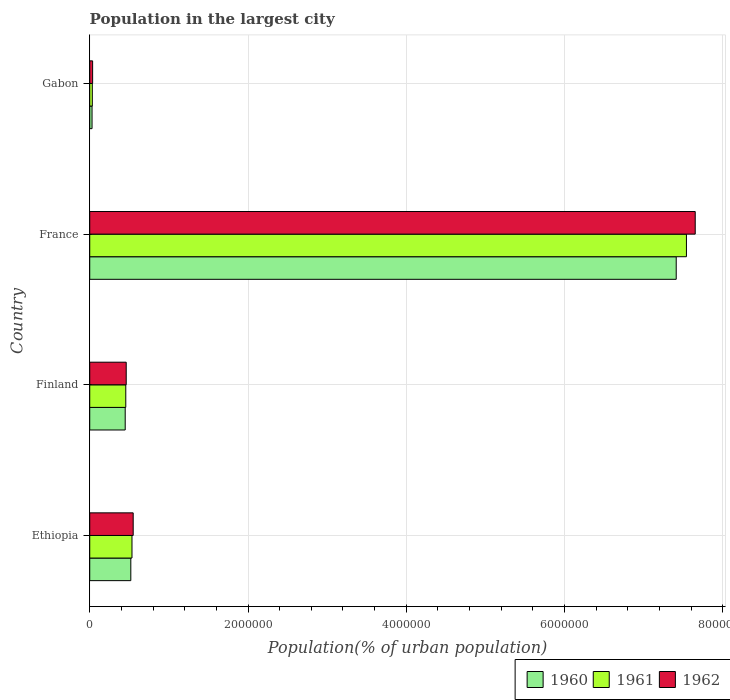How many different coloured bars are there?
Your response must be concise. 3. Are the number of bars on each tick of the Y-axis equal?
Provide a short and direct response. Yes. How many bars are there on the 3rd tick from the bottom?
Provide a short and direct response. 3. What is the label of the 3rd group of bars from the top?
Provide a short and direct response. Finland. What is the population in the largest city in 1960 in Gabon?
Provide a succinct answer. 2.92e+04. Across all countries, what is the maximum population in the largest city in 1961?
Make the answer very short. 7.54e+06. Across all countries, what is the minimum population in the largest city in 1960?
Offer a terse response. 2.92e+04. In which country was the population in the largest city in 1962 minimum?
Offer a terse response. Gabon. What is the total population in the largest city in 1960 in the graph?
Offer a very short reply. 8.41e+06. What is the difference between the population in the largest city in 1960 in Ethiopia and that in France?
Keep it short and to the point. -6.89e+06. What is the difference between the population in the largest city in 1960 in France and the population in the largest city in 1961 in Finland?
Ensure brevity in your answer.  6.96e+06. What is the average population in the largest city in 1962 per country?
Your answer should be compact. 2.17e+06. What is the difference between the population in the largest city in 1960 and population in the largest city in 1961 in France?
Give a very brief answer. -1.29e+05. What is the ratio of the population in the largest city in 1961 in France to that in Gabon?
Your response must be concise. 231.24. What is the difference between the highest and the second highest population in the largest city in 1962?
Offer a terse response. 7.10e+06. What is the difference between the highest and the lowest population in the largest city in 1961?
Offer a terse response. 7.51e+06. Is the sum of the population in the largest city in 1960 in Finland and Gabon greater than the maximum population in the largest city in 1961 across all countries?
Your answer should be compact. No. What does the 1st bar from the bottom in Finland represents?
Your answer should be very brief. 1960. How many bars are there?
Provide a short and direct response. 12. Are all the bars in the graph horizontal?
Ensure brevity in your answer.  Yes. How many countries are there in the graph?
Your answer should be compact. 4. What is the difference between two consecutive major ticks on the X-axis?
Keep it short and to the point. 2.00e+06. Are the values on the major ticks of X-axis written in scientific E-notation?
Ensure brevity in your answer.  No. Does the graph contain any zero values?
Give a very brief answer. No. Where does the legend appear in the graph?
Offer a terse response. Bottom right. How many legend labels are there?
Provide a short and direct response. 3. What is the title of the graph?
Your response must be concise. Population in the largest city. Does "2005" appear as one of the legend labels in the graph?
Provide a succinct answer. No. What is the label or title of the X-axis?
Keep it short and to the point. Population(% of urban population). What is the Population(% of urban population) of 1960 in Ethiopia?
Offer a very short reply. 5.19e+05. What is the Population(% of urban population) in 1961 in Ethiopia?
Your answer should be very brief. 5.34e+05. What is the Population(% of urban population) of 1962 in Ethiopia?
Offer a terse response. 5.49e+05. What is the Population(% of urban population) of 1960 in Finland?
Offer a very short reply. 4.48e+05. What is the Population(% of urban population) of 1961 in Finland?
Offer a terse response. 4.55e+05. What is the Population(% of urban population) in 1962 in Finland?
Your response must be concise. 4.61e+05. What is the Population(% of urban population) of 1960 in France?
Make the answer very short. 7.41e+06. What is the Population(% of urban population) of 1961 in France?
Your answer should be very brief. 7.54e+06. What is the Population(% of urban population) of 1962 in France?
Your response must be concise. 7.65e+06. What is the Population(% of urban population) in 1960 in Gabon?
Give a very brief answer. 2.92e+04. What is the Population(% of urban population) in 1961 in Gabon?
Offer a terse response. 3.26e+04. What is the Population(% of urban population) in 1962 in Gabon?
Make the answer very short. 3.65e+04. Across all countries, what is the maximum Population(% of urban population) of 1960?
Your answer should be compact. 7.41e+06. Across all countries, what is the maximum Population(% of urban population) of 1961?
Keep it short and to the point. 7.54e+06. Across all countries, what is the maximum Population(% of urban population) of 1962?
Provide a succinct answer. 7.65e+06. Across all countries, what is the minimum Population(% of urban population) in 1960?
Offer a very short reply. 2.92e+04. Across all countries, what is the minimum Population(% of urban population) in 1961?
Offer a very short reply. 3.26e+04. Across all countries, what is the minimum Population(% of urban population) of 1962?
Make the answer very short. 3.65e+04. What is the total Population(% of urban population) of 1960 in the graph?
Offer a terse response. 8.41e+06. What is the total Population(% of urban population) of 1961 in the graph?
Your answer should be compact. 8.56e+06. What is the total Population(% of urban population) in 1962 in the graph?
Your response must be concise. 8.70e+06. What is the difference between the Population(% of urban population) in 1960 in Ethiopia and that in Finland?
Make the answer very short. 7.10e+04. What is the difference between the Population(% of urban population) in 1961 in Ethiopia and that in Finland?
Give a very brief answer. 7.85e+04. What is the difference between the Population(% of urban population) of 1962 in Ethiopia and that in Finland?
Your answer should be very brief. 8.82e+04. What is the difference between the Population(% of urban population) in 1960 in Ethiopia and that in France?
Give a very brief answer. -6.89e+06. What is the difference between the Population(% of urban population) in 1961 in Ethiopia and that in France?
Your answer should be compact. -7.01e+06. What is the difference between the Population(% of urban population) of 1962 in Ethiopia and that in France?
Ensure brevity in your answer.  -7.10e+06. What is the difference between the Population(% of urban population) in 1960 in Ethiopia and that in Gabon?
Keep it short and to the point. 4.90e+05. What is the difference between the Population(% of urban population) in 1961 in Ethiopia and that in Gabon?
Offer a very short reply. 5.01e+05. What is the difference between the Population(% of urban population) in 1962 in Ethiopia and that in Gabon?
Your answer should be very brief. 5.13e+05. What is the difference between the Population(% of urban population) of 1960 in Finland and that in France?
Offer a terse response. -6.96e+06. What is the difference between the Population(% of urban population) in 1961 in Finland and that in France?
Make the answer very short. -7.08e+06. What is the difference between the Population(% of urban population) in 1962 in Finland and that in France?
Offer a terse response. -7.19e+06. What is the difference between the Population(% of urban population) in 1960 in Finland and that in Gabon?
Your answer should be very brief. 4.19e+05. What is the difference between the Population(% of urban population) in 1961 in Finland and that in Gabon?
Offer a terse response. 4.23e+05. What is the difference between the Population(% of urban population) of 1962 in Finland and that in Gabon?
Offer a very short reply. 4.24e+05. What is the difference between the Population(% of urban population) of 1960 in France and that in Gabon?
Your answer should be very brief. 7.38e+06. What is the difference between the Population(% of urban population) of 1961 in France and that in Gabon?
Keep it short and to the point. 7.51e+06. What is the difference between the Population(% of urban population) of 1962 in France and that in Gabon?
Ensure brevity in your answer.  7.61e+06. What is the difference between the Population(% of urban population) of 1960 in Ethiopia and the Population(% of urban population) of 1961 in Finland?
Provide a succinct answer. 6.37e+04. What is the difference between the Population(% of urban population) in 1960 in Ethiopia and the Population(% of urban population) in 1962 in Finland?
Your answer should be very brief. 5.82e+04. What is the difference between the Population(% of urban population) of 1961 in Ethiopia and the Population(% of urban population) of 1962 in Finland?
Your response must be concise. 7.30e+04. What is the difference between the Population(% of urban population) of 1960 in Ethiopia and the Population(% of urban population) of 1961 in France?
Offer a terse response. -7.02e+06. What is the difference between the Population(% of urban population) in 1960 in Ethiopia and the Population(% of urban population) in 1962 in France?
Offer a terse response. -7.13e+06. What is the difference between the Population(% of urban population) in 1961 in Ethiopia and the Population(% of urban population) in 1962 in France?
Provide a succinct answer. -7.12e+06. What is the difference between the Population(% of urban population) in 1960 in Ethiopia and the Population(% of urban population) in 1961 in Gabon?
Make the answer very short. 4.87e+05. What is the difference between the Population(% of urban population) of 1960 in Ethiopia and the Population(% of urban population) of 1962 in Gabon?
Offer a very short reply. 4.83e+05. What is the difference between the Population(% of urban population) of 1961 in Ethiopia and the Population(% of urban population) of 1962 in Gabon?
Your response must be concise. 4.97e+05. What is the difference between the Population(% of urban population) in 1960 in Finland and the Population(% of urban population) in 1961 in France?
Your answer should be very brief. -7.09e+06. What is the difference between the Population(% of urban population) in 1960 in Finland and the Population(% of urban population) in 1962 in France?
Ensure brevity in your answer.  -7.20e+06. What is the difference between the Population(% of urban population) of 1961 in Finland and the Population(% of urban population) of 1962 in France?
Your response must be concise. -7.20e+06. What is the difference between the Population(% of urban population) of 1960 in Finland and the Population(% of urban population) of 1961 in Gabon?
Provide a succinct answer. 4.16e+05. What is the difference between the Population(% of urban population) in 1960 in Finland and the Population(% of urban population) in 1962 in Gabon?
Keep it short and to the point. 4.12e+05. What is the difference between the Population(% of urban population) of 1961 in Finland and the Population(% of urban population) of 1962 in Gabon?
Your answer should be compact. 4.19e+05. What is the difference between the Population(% of urban population) in 1960 in France and the Population(% of urban population) in 1961 in Gabon?
Provide a succinct answer. 7.38e+06. What is the difference between the Population(% of urban population) in 1960 in France and the Population(% of urban population) in 1962 in Gabon?
Give a very brief answer. 7.37e+06. What is the difference between the Population(% of urban population) of 1961 in France and the Population(% of urban population) of 1962 in Gabon?
Make the answer very short. 7.50e+06. What is the average Population(% of urban population) in 1960 per country?
Offer a very short reply. 2.10e+06. What is the average Population(% of urban population) of 1961 per country?
Ensure brevity in your answer.  2.14e+06. What is the average Population(% of urban population) in 1962 per country?
Provide a succinct answer. 2.17e+06. What is the difference between the Population(% of urban population) in 1960 and Population(% of urban population) in 1961 in Ethiopia?
Provide a succinct answer. -1.48e+04. What is the difference between the Population(% of urban population) in 1960 and Population(% of urban population) in 1962 in Ethiopia?
Ensure brevity in your answer.  -3.00e+04. What is the difference between the Population(% of urban population) of 1961 and Population(% of urban population) of 1962 in Ethiopia?
Your response must be concise. -1.52e+04. What is the difference between the Population(% of urban population) of 1960 and Population(% of urban population) of 1961 in Finland?
Provide a succinct answer. -7296. What is the difference between the Population(% of urban population) of 1960 and Population(% of urban population) of 1962 in Finland?
Ensure brevity in your answer.  -1.28e+04. What is the difference between the Population(% of urban population) in 1961 and Population(% of urban population) in 1962 in Finland?
Ensure brevity in your answer.  -5485. What is the difference between the Population(% of urban population) of 1960 and Population(% of urban population) of 1961 in France?
Your answer should be very brief. -1.29e+05. What is the difference between the Population(% of urban population) in 1960 and Population(% of urban population) in 1962 in France?
Your answer should be very brief. -2.40e+05. What is the difference between the Population(% of urban population) of 1961 and Population(% of urban population) of 1962 in France?
Make the answer very short. -1.11e+05. What is the difference between the Population(% of urban population) in 1960 and Population(% of urban population) in 1961 in Gabon?
Provide a short and direct response. -3358. What is the difference between the Population(% of urban population) of 1960 and Population(% of urban population) of 1962 in Gabon?
Your answer should be very brief. -7295. What is the difference between the Population(% of urban population) in 1961 and Population(% of urban population) in 1962 in Gabon?
Make the answer very short. -3937. What is the ratio of the Population(% of urban population) in 1960 in Ethiopia to that in Finland?
Give a very brief answer. 1.16. What is the ratio of the Population(% of urban population) of 1961 in Ethiopia to that in Finland?
Provide a short and direct response. 1.17. What is the ratio of the Population(% of urban population) in 1962 in Ethiopia to that in Finland?
Provide a succinct answer. 1.19. What is the ratio of the Population(% of urban population) of 1960 in Ethiopia to that in France?
Offer a terse response. 0.07. What is the ratio of the Population(% of urban population) of 1961 in Ethiopia to that in France?
Ensure brevity in your answer.  0.07. What is the ratio of the Population(% of urban population) of 1962 in Ethiopia to that in France?
Ensure brevity in your answer.  0.07. What is the ratio of the Population(% of urban population) in 1960 in Ethiopia to that in Gabon?
Offer a very short reply. 17.75. What is the ratio of the Population(% of urban population) in 1961 in Ethiopia to that in Gabon?
Make the answer very short. 16.38. What is the ratio of the Population(% of urban population) of 1962 in Ethiopia to that in Gabon?
Ensure brevity in your answer.  15.03. What is the ratio of the Population(% of urban population) of 1960 in Finland to that in France?
Provide a succinct answer. 0.06. What is the ratio of the Population(% of urban population) in 1961 in Finland to that in France?
Offer a terse response. 0.06. What is the ratio of the Population(% of urban population) of 1962 in Finland to that in France?
Keep it short and to the point. 0.06. What is the ratio of the Population(% of urban population) in 1960 in Finland to that in Gabon?
Give a very brief answer. 15.32. What is the ratio of the Population(% of urban population) of 1961 in Finland to that in Gabon?
Give a very brief answer. 13.97. What is the ratio of the Population(% of urban population) in 1962 in Finland to that in Gabon?
Make the answer very short. 12.61. What is the ratio of the Population(% of urban population) of 1960 in France to that in Gabon?
Keep it short and to the point. 253.37. What is the ratio of the Population(% of urban population) of 1961 in France to that in Gabon?
Give a very brief answer. 231.24. What is the ratio of the Population(% of urban population) of 1962 in France to that in Gabon?
Offer a terse response. 209.36. What is the difference between the highest and the second highest Population(% of urban population) of 1960?
Provide a short and direct response. 6.89e+06. What is the difference between the highest and the second highest Population(% of urban population) in 1961?
Provide a succinct answer. 7.01e+06. What is the difference between the highest and the second highest Population(% of urban population) in 1962?
Your answer should be compact. 7.10e+06. What is the difference between the highest and the lowest Population(% of urban population) of 1960?
Offer a very short reply. 7.38e+06. What is the difference between the highest and the lowest Population(% of urban population) of 1961?
Give a very brief answer. 7.51e+06. What is the difference between the highest and the lowest Population(% of urban population) in 1962?
Keep it short and to the point. 7.61e+06. 